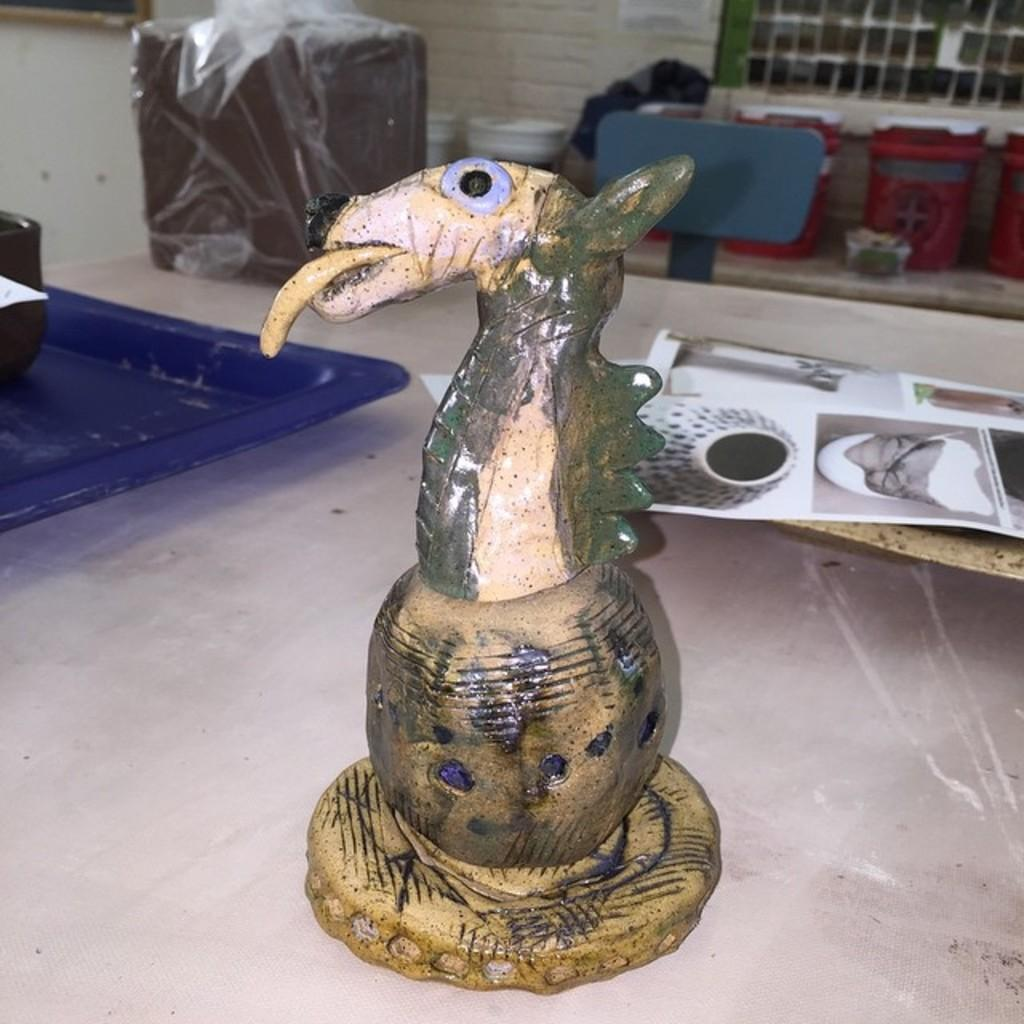What is the main subject in the image? There is a sculpture in the image. What is located near the sculpture? There is a tray in the image. What else can be seen in the image besides the sculpture and tray? There are papers and objects on a platform in the image. What can be seen in the background of the image? There is a wall and objects visible in the background of the image. What time of day is depicted in the image? The image does not provide any information about the time of day, so it cannot be determined. 